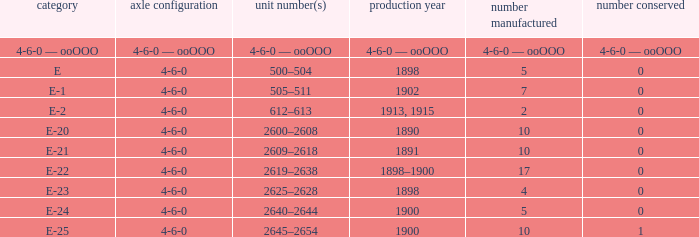What is the quantity preserved of the e-1 class? 0.0. 